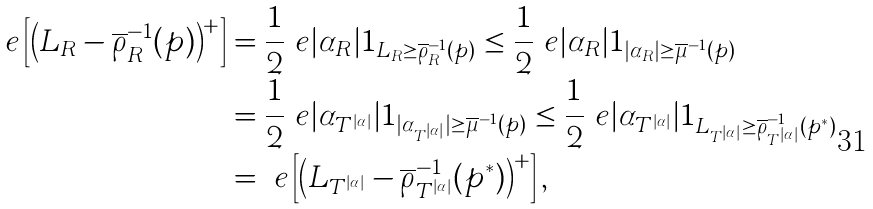Convert formula to latex. <formula><loc_0><loc_0><loc_500><loc_500>\ e \left [ \left ( L _ { R } - \overline { \rho } _ { R } ^ { - 1 } ( p ) \right ) ^ { + } \right ] & = \frac { 1 } { 2 } \ e | \alpha _ { R } | 1 _ { L _ { R } \geq \overline { \rho } _ { R } ^ { - 1 } ( p ) } \leq \frac { 1 } { 2 } \ e | \alpha _ { R } | 1 _ { | \alpha _ { R } | \geq \overline { \mu } ^ { - 1 } ( p ) } \\ & = \frac { 1 } { 2 } \ e | \alpha _ { T ^ { | \alpha | } } | 1 _ { | \alpha _ { T ^ { | \alpha | } } | \geq \overline { \mu } ^ { - 1 } ( p ) } \leq \frac { 1 } { 2 } \ e | \alpha _ { T ^ { | \alpha | } } | 1 _ { L _ { T ^ { | \alpha | } } \geq \overline { \rho } _ { T ^ { | \alpha | } } ^ { - 1 } ( p ^ { * } ) } \\ & = \ e \left [ \left ( L _ { T ^ { | \alpha | } } - \overline { \rho } _ { T ^ { | \alpha | } } ^ { - 1 } ( p ^ { * } ) \right ) ^ { + } \right ] ,</formula> 